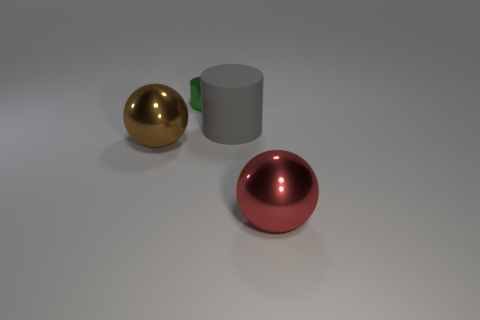How many other objects are there of the same size as the green object?
Ensure brevity in your answer.  0. How many objects are big metallic objects that are on the right side of the metal cylinder or red shiny objects to the right of the big gray matte cylinder?
Ensure brevity in your answer.  1. Are there fewer tiny green metallic things that are to the right of the matte thing than purple metallic objects?
Offer a terse response. No. Is there a sphere that has the same size as the red shiny object?
Give a very brief answer. Yes. The large rubber object has what color?
Give a very brief answer. Gray. Does the matte cylinder have the same size as the red ball?
Ensure brevity in your answer.  Yes. How many things are either big spheres or big brown matte blocks?
Your response must be concise. 2. Are there the same number of small green shiny cylinders that are behind the gray rubber thing and blue blocks?
Offer a terse response. No. Are there any small green cylinders right of the shiny object that is in front of the large metal thing on the left side of the red metallic ball?
Make the answer very short. No. The cylinder that is made of the same material as the brown sphere is what color?
Provide a succinct answer. Green. 